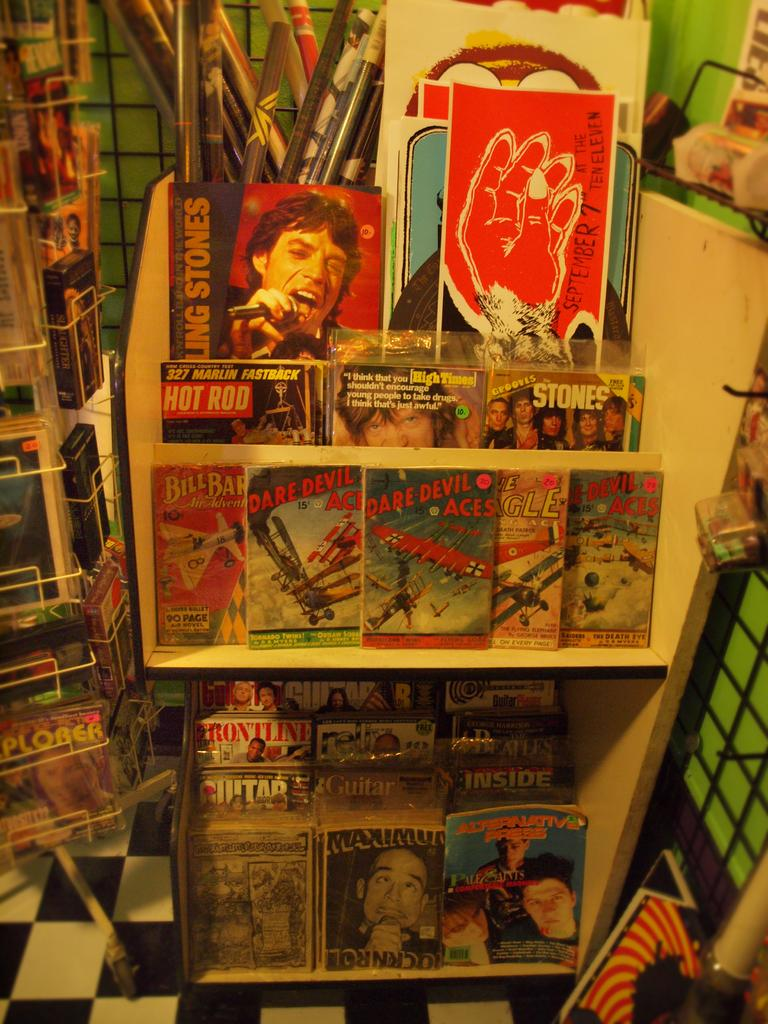<image>
Write a terse but informative summary of the picture. A display with magazines like Frontline and comics like Daredevil Aces. 